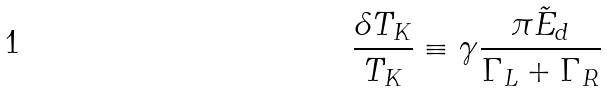Convert formula to latex. <formula><loc_0><loc_0><loc_500><loc_500>\frac { \delta T _ { K } } { T _ { K } } \equiv \gamma \frac { \pi \tilde { E } _ { d } } { \Gamma _ { L } + \Gamma _ { R } } \,</formula> 